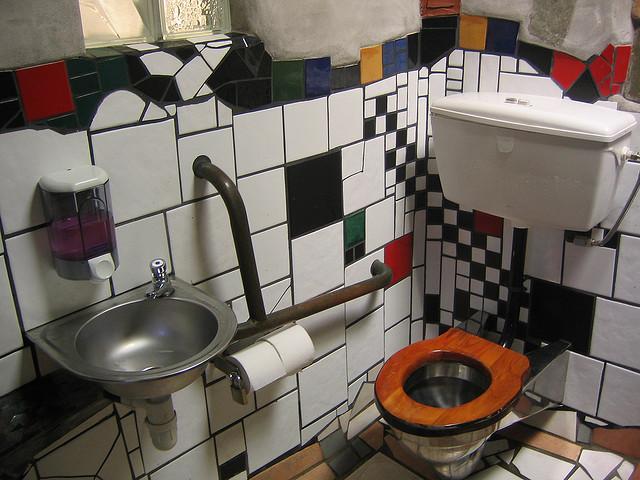How many rolls of toilet paper are there?
Keep it brief. 2. What is on the walls?
Quick response, please. Tiles. What is the toilet seat made out of?
Keep it brief. Wood. 